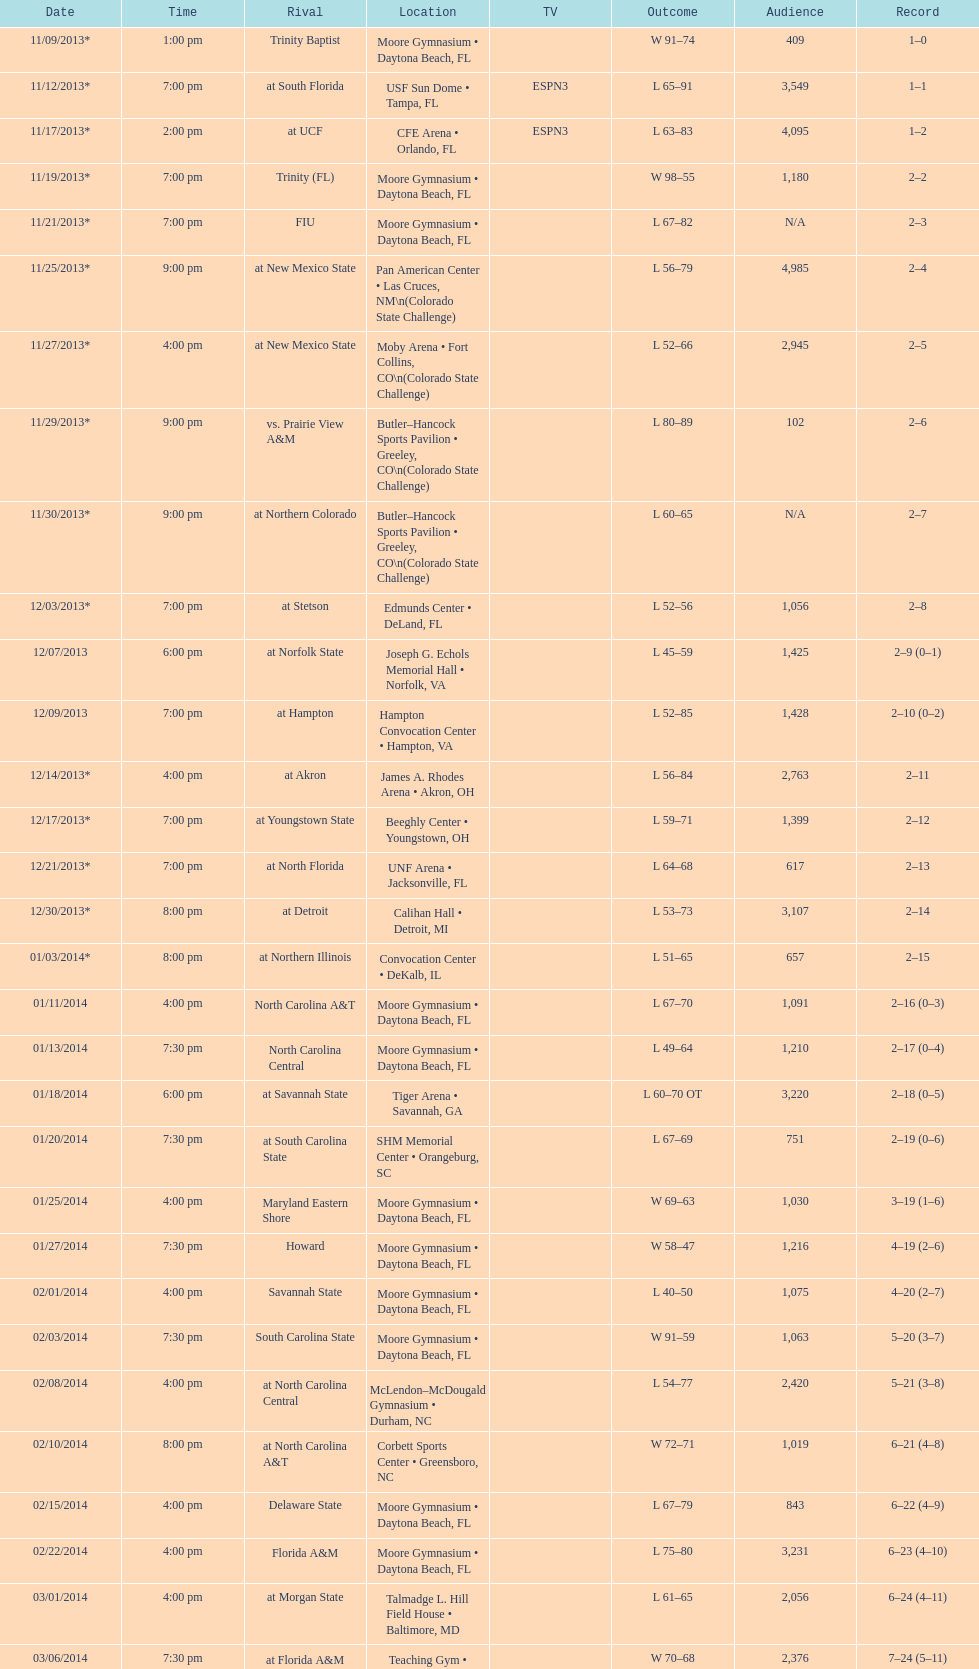How many games had more than 1,500 in attendance? 12. Give me the full table as a dictionary. {'header': ['Date', 'Time', 'Rival', 'Location', 'TV', 'Outcome', 'Audience', 'Record'], 'rows': [['11/09/2013*', '1:00 pm', 'Trinity Baptist', 'Moore Gymnasium • Daytona Beach, FL', '', 'W\xa091–74', '409', '1–0'], ['11/12/2013*', '7:00 pm', 'at\xa0South Florida', 'USF Sun Dome • Tampa, FL', 'ESPN3', 'L\xa065–91', '3,549', '1–1'], ['11/17/2013*', '2:00 pm', 'at\xa0UCF', 'CFE Arena • Orlando, FL', 'ESPN3', 'L\xa063–83', '4,095', '1–2'], ['11/19/2013*', '7:00 pm', 'Trinity (FL)', 'Moore Gymnasium • Daytona Beach, FL', '', 'W\xa098–55', '1,180', '2–2'], ['11/21/2013*', '7:00 pm', 'FIU', 'Moore Gymnasium • Daytona Beach, FL', '', 'L\xa067–82', 'N/A', '2–3'], ['11/25/2013*', '9:00 pm', 'at\xa0New Mexico State', 'Pan American Center • Las Cruces, NM\\n(Colorado State Challenge)', '', 'L\xa056–79', '4,985', '2–4'], ['11/27/2013*', '4:00 pm', 'at\xa0New Mexico State', 'Moby Arena • Fort Collins, CO\\n(Colorado State Challenge)', '', 'L\xa052–66', '2,945', '2–5'], ['11/29/2013*', '9:00 pm', 'vs.\xa0Prairie View A&M', 'Butler–Hancock Sports Pavilion • Greeley, CO\\n(Colorado State Challenge)', '', 'L\xa080–89', '102', '2–6'], ['11/30/2013*', '9:00 pm', 'at\xa0Northern Colorado', 'Butler–Hancock Sports Pavilion • Greeley, CO\\n(Colorado State Challenge)', '', 'L\xa060–65', 'N/A', '2–7'], ['12/03/2013*', '7:00 pm', 'at\xa0Stetson', 'Edmunds Center • DeLand, FL', '', 'L\xa052–56', '1,056', '2–8'], ['12/07/2013', '6:00 pm', 'at\xa0Norfolk State', 'Joseph G. Echols Memorial Hall • Norfolk, VA', '', 'L\xa045–59', '1,425', '2–9 (0–1)'], ['12/09/2013', '7:00 pm', 'at\xa0Hampton', 'Hampton Convocation Center • Hampton, VA', '', 'L\xa052–85', '1,428', '2–10 (0–2)'], ['12/14/2013*', '4:00 pm', 'at\xa0Akron', 'James A. Rhodes Arena • Akron, OH', '', 'L\xa056–84', '2,763', '2–11'], ['12/17/2013*', '7:00 pm', 'at\xa0Youngstown State', 'Beeghly Center • Youngstown, OH', '', 'L\xa059–71', '1,399', '2–12'], ['12/21/2013*', '7:00 pm', 'at\xa0North Florida', 'UNF Arena • Jacksonville, FL', '', 'L\xa064–68', '617', '2–13'], ['12/30/2013*', '8:00 pm', 'at\xa0Detroit', 'Calihan Hall • Detroit, MI', '', 'L\xa053–73', '3,107', '2–14'], ['01/03/2014*', '8:00 pm', 'at\xa0Northern Illinois', 'Convocation Center • DeKalb, IL', '', 'L\xa051–65', '657', '2–15'], ['01/11/2014', '4:00 pm', 'North Carolina A&T', 'Moore Gymnasium • Daytona Beach, FL', '', 'L\xa067–70', '1,091', '2–16 (0–3)'], ['01/13/2014', '7:30 pm', 'North Carolina Central', 'Moore Gymnasium • Daytona Beach, FL', '', 'L\xa049–64', '1,210', '2–17 (0–4)'], ['01/18/2014', '6:00 pm', 'at\xa0Savannah State', 'Tiger Arena • Savannah, GA', '', 'L\xa060–70\xa0OT', '3,220', '2–18 (0–5)'], ['01/20/2014', '7:30 pm', 'at\xa0South Carolina State', 'SHM Memorial Center • Orangeburg, SC', '', 'L\xa067–69', '751', '2–19 (0–6)'], ['01/25/2014', '4:00 pm', 'Maryland Eastern Shore', 'Moore Gymnasium • Daytona Beach, FL', '', 'W\xa069–63', '1,030', '3–19 (1–6)'], ['01/27/2014', '7:30 pm', 'Howard', 'Moore Gymnasium • Daytona Beach, FL', '', 'W\xa058–47', '1,216', '4–19 (2–6)'], ['02/01/2014', '4:00 pm', 'Savannah State', 'Moore Gymnasium • Daytona Beach, FL', '', 'L\xa040–50', '1,075', '4–20 (2–7)'], ['02/03/2014', '7:30 pm', 'South Carolina State', 'Moore Gymnasium • Daytona Beach, FL', '', 'W\xa091–59', '1,063', '5–20 (3–7)'], ['02/08/2014', '4:00 pm', 'at\xa0North Carolina Central', 'McLendon–McDougald Gymnasium • Durham, NC', '', 'L\xa054–77', '2,420', '5–21 (3–8)'], ['02/10/2014', '8:00 pm', 'at\xa0North Carolina A&T', 'Corbett Sports Center • Greensboro, NC', '', 'W\xa072–71', '1,019', '6–21 (4–8)'], ['02/15/2014', '4:00 pm', 'Delaware State', 'Moore Gymnasium • Daytona Beach, FL', '', 'L\xa067–79', '843', '6–22 (4–9)'], ['02/22/2014', '4:00 pm', 'Florida A&M', 'Moore Gymnasium • Daytona Beach, FL', '', 'L\xa075–80', '3,231', '6–23 (4–10)'], ['03/01/2014', '4:00 pm', 'at\xa0Morgan State', 'Talmadge L. Hill Field House • Baltimore, MD', '', 'L\xa061–65', '2,056', '6–24 (4–11)'], ['03/06/2014', '7:30 pm', 'at\xa0Florida A&M', 'Teaching Gym • Tallahassee, FL', '', 'W\xa070–68', '2,376', '7–24 (5–11)'], ['03/11/2014', '6:30 pm', 'vs.\xa0Coppin State', 'Norfolk Scope • Norfolk, VA\\n(First round)', '', 'L\xa068–75', '4,658', '7–25']]} 